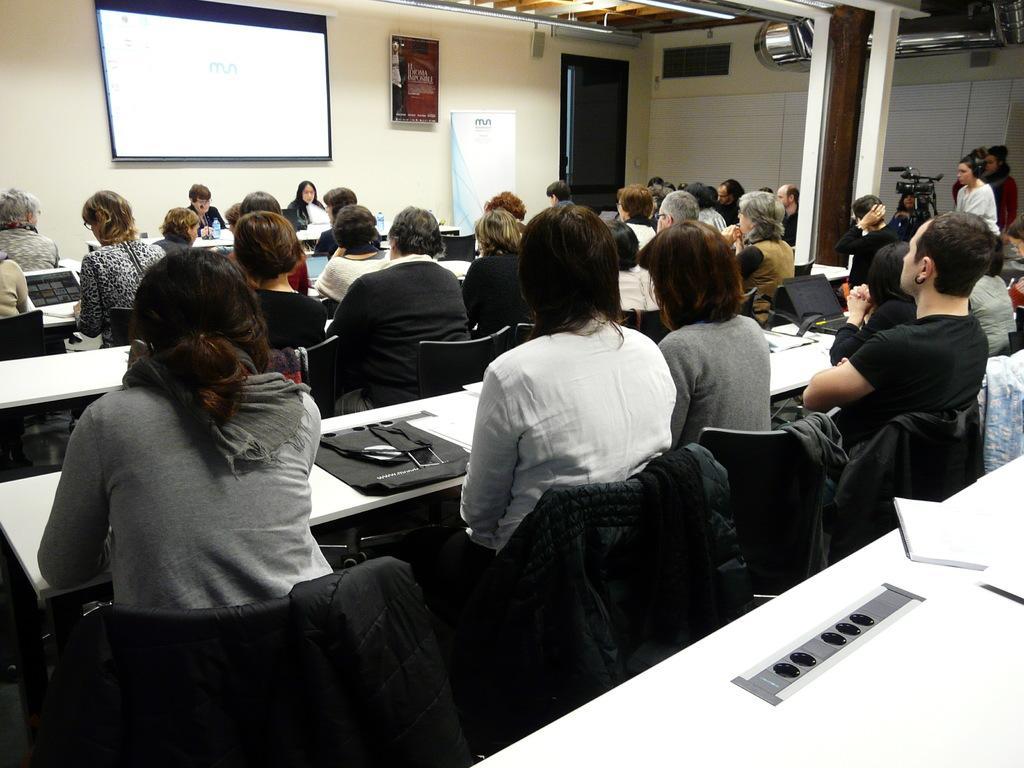Could you give a brief overview of what you see in this image? In this picture number of people visible and all of are sitting in the chair and back side of the image there is a wall and a screen attached to the wall. And there is notice paper attached to the wall and some text written on that. On the right side there is a door. And there is a beam on the right side corner and left to the beam there is a bicycle kept on the floor. And there is laptop on the table. 